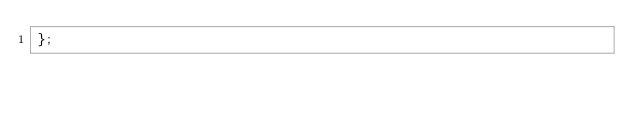<code> <loc_0><loc_0><loc_500><loc_500><_JavaScript_>};
</code> 